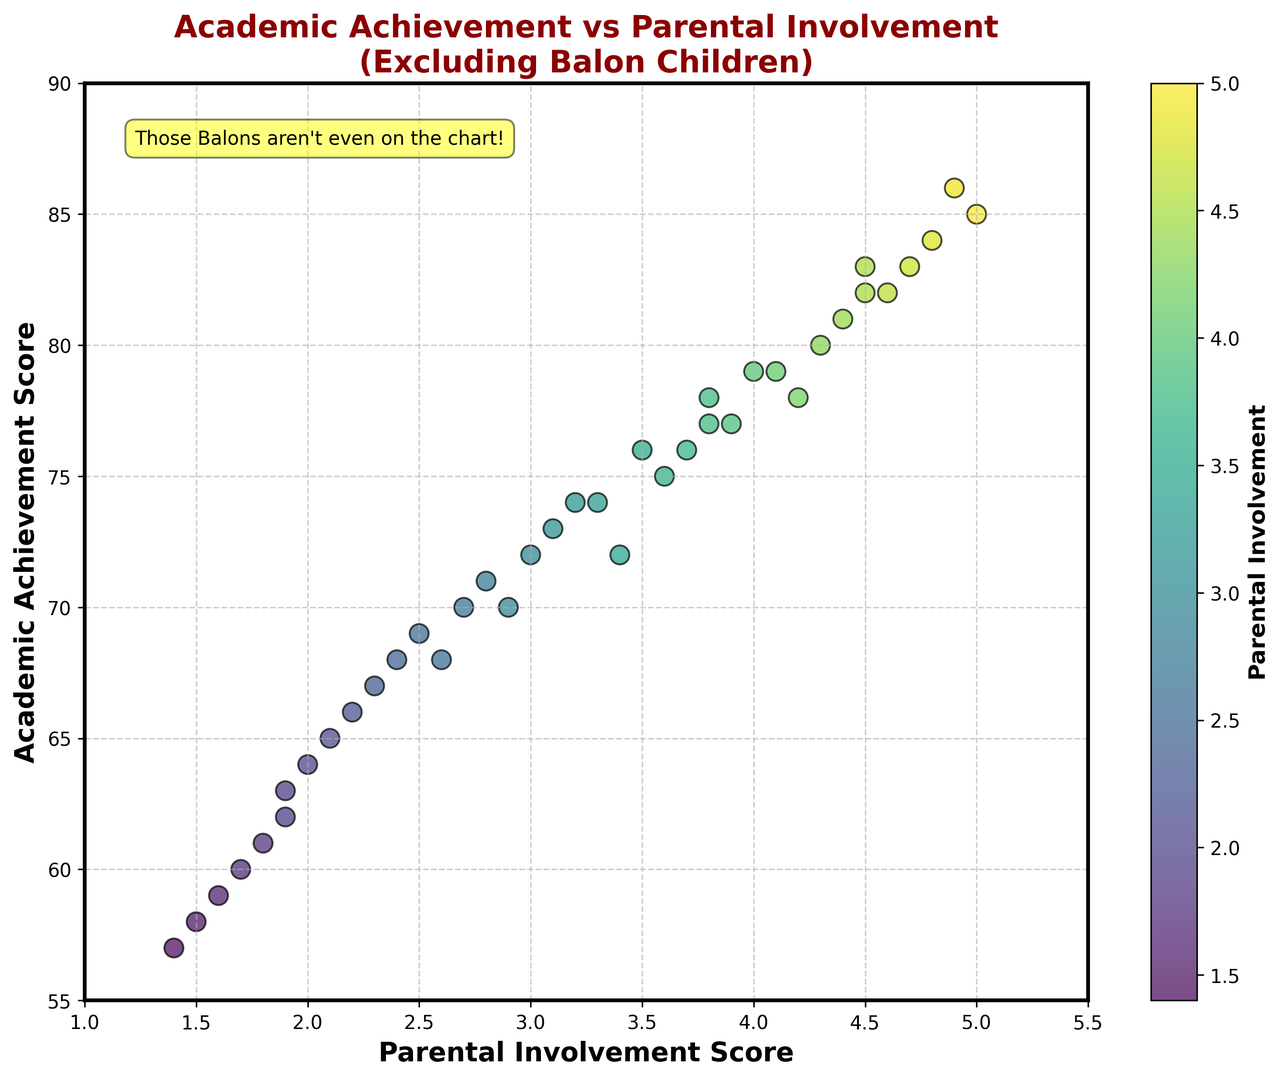What's the highest Academic Achievement Score on the plot? Look for the point with the maximum y-value on the plot. The highest value of the Academic Achievement Score is around 86.
Answer: 86 Is there a general trend between Parental Involvement and Academic Achievement? Observe the overall distribution of points. There is a clear positive trend, meaning that higher Parental Involvement Scores are associated with higher Academic Achievement Scores.
Answer: Positive trend Which score has a greater value, the Academic Achievement Score at the lowest Parental Involvement Score or the Academic Achievement Score at the highest Parental Involvement Score? Find the Academic Achievement Scores corresponding to the lowest and highest Parental Involvement Scores (1.4 and 5.0, respectively). The Academic Achievement Score is higher for the highest Parental Involvement Score.
Answer: Highest Parental Involvement Score (85) How many data points have a Parental Involvement Score greater than 4.0? Count the number of points with Parental Involvement Scores above 4.0. There are eight such points.
Answer: 8 What is the difference between the highest and lowest Academic Achievement Scores on the plot? The highest Academic Achievement Score is 86 and the lowest is 57. The difference is 86 - 57 = 29.
Answer: 29 Which region (lower-left, lower-right, upper-left, upper-right) has the most data points? Observe the four quadrants of the plot. The upper-right quadrant (high Academic Achievement and high Parental Involvement Scores) has the most data points.
Answer: Upper-right quadrant What is the Academic Achievement Score of the student with a Parental Involvement Score of 3.5? Locate the data point with a Parental Involvement Score of 3.5. The corresponding Academic Achievement Score is 76.
Answer: 76 What color represents high Parental Involvement Scores on the plot? Observe the color scale on the plot. High Parental Involvement Scores are represented by greenish colors.
Answer: Greenish 